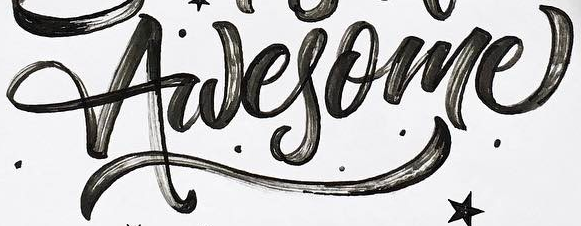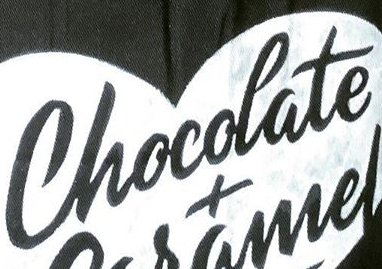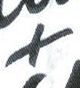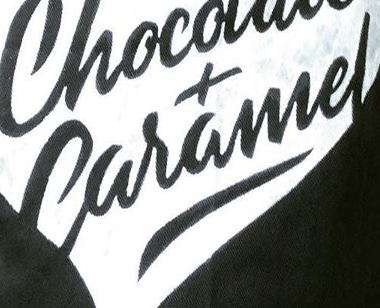Transcribe the words shown in these images in order, separated by a semicolon. Awesome; Chocolate; +; Caramel 